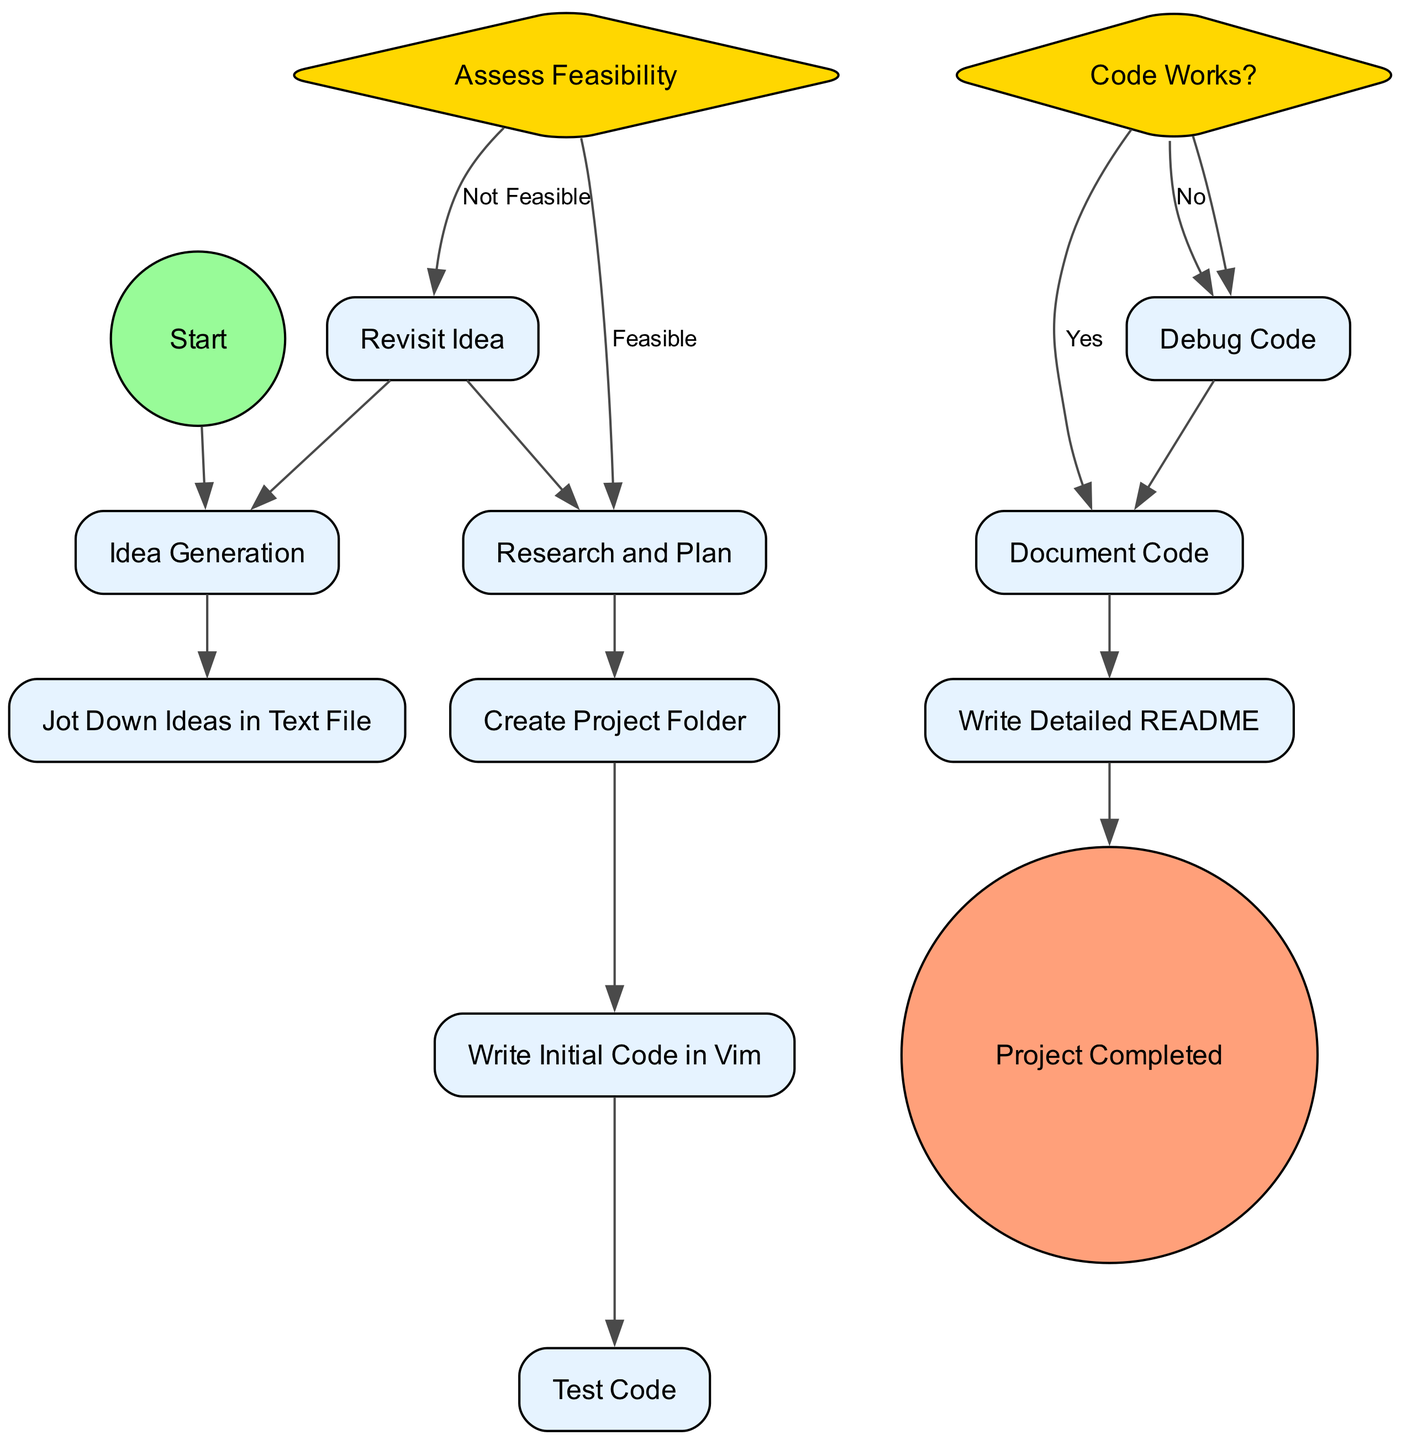What is the first activity in the workflow? The first activity node in the diagram is "Idea Generation" which follows the "Start" node. It marks the beginning of the project management workflow.
Answer: Idea Generation How many decision nodes are in the diagram? There are two decision nodes in the diagram: "Assess Feasibility" and "Code Works?". Hence, the total count is 2.
Answer: 2 What happens if the code does not work? If the code does not work, the workflow directs to the "Debug Code" activity according to the decision node "Code Works?".
Answer: Debug Code What is the output of the "Assess Feasibility" decision if the idea is feasible? If the idea is feasible, it proceeds to the "Research and Plan" activity as indicated by the arrows connecting the options to the activities.
Answer: Research and Plan What activity occurs after creating the project folder? After "Create Project Folder," the next activity is "Write Initial Code in Vim" based on the flow of the diagram represented by the edges.
Answer: Write Initial Code in Vim What is the last step before the project is marked as completed? The last step before marking the project complete is "Write Detailed README," indicating all documentation is finalized before ending the workflow.
Answer: Write Detailed README If the feasibility assessment results in "Not Feasible," which activity follows? If the feasibility assessment results in "Not Feasible," it routes back to the "Revisit Idea" activity based on the decision node options available.
Answer: Revisit Idea What type of node is "Document Code"? "Document Code" is an activity node, as specified within the workflow, distinct from start, end, or decision types.
Answer: Activity 